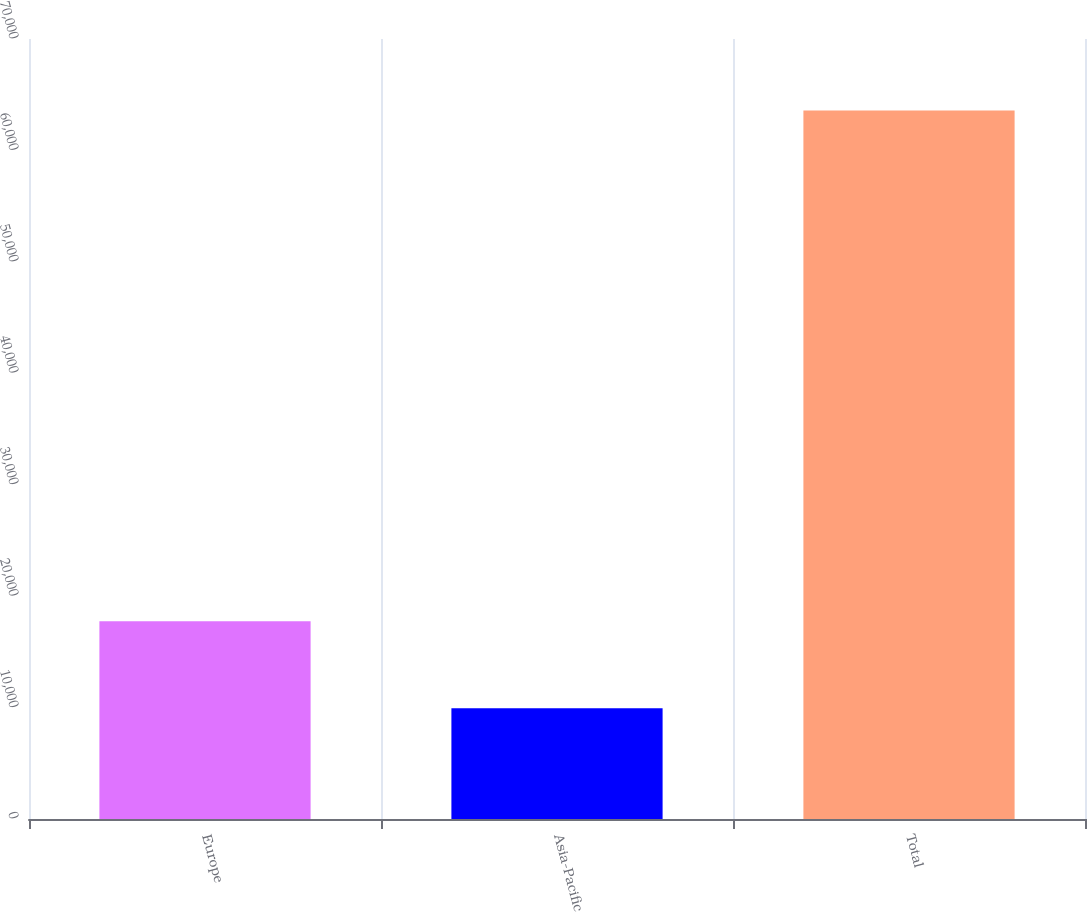<chart> <loc_0><loc_0><loc_500><loc_500><bar_chart><fcel>Europe<fcel>Asia-Pacific<fcel>Total<nl><fcel>17755<fcel>9929<fcel>63584<nl></chart> 